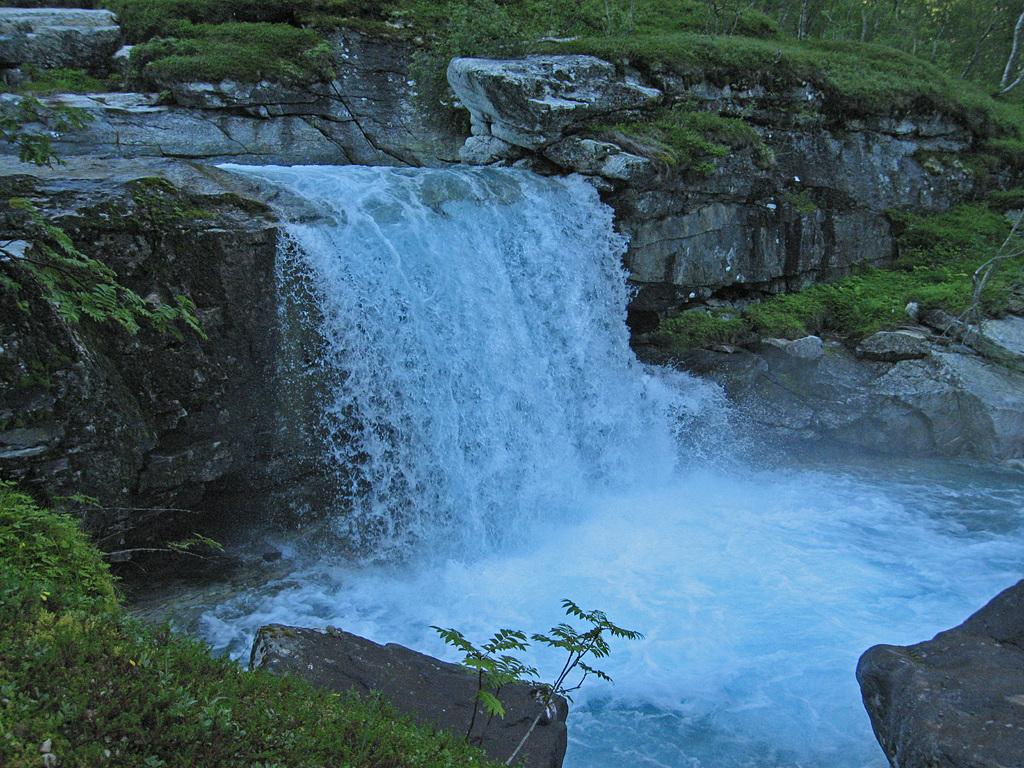What natural feature is the main subject of the image? There is a waterfall in the image. Where does the waterfall originate from? The waterfall is flowing from the mountains. What type of vegetation can be seen in the image? Grass and trees are present in the image. What type of waves can be seen crashing on the shore in the image? There are no waves or shore present in the image; it features a waterfall flowing from the mountains. 